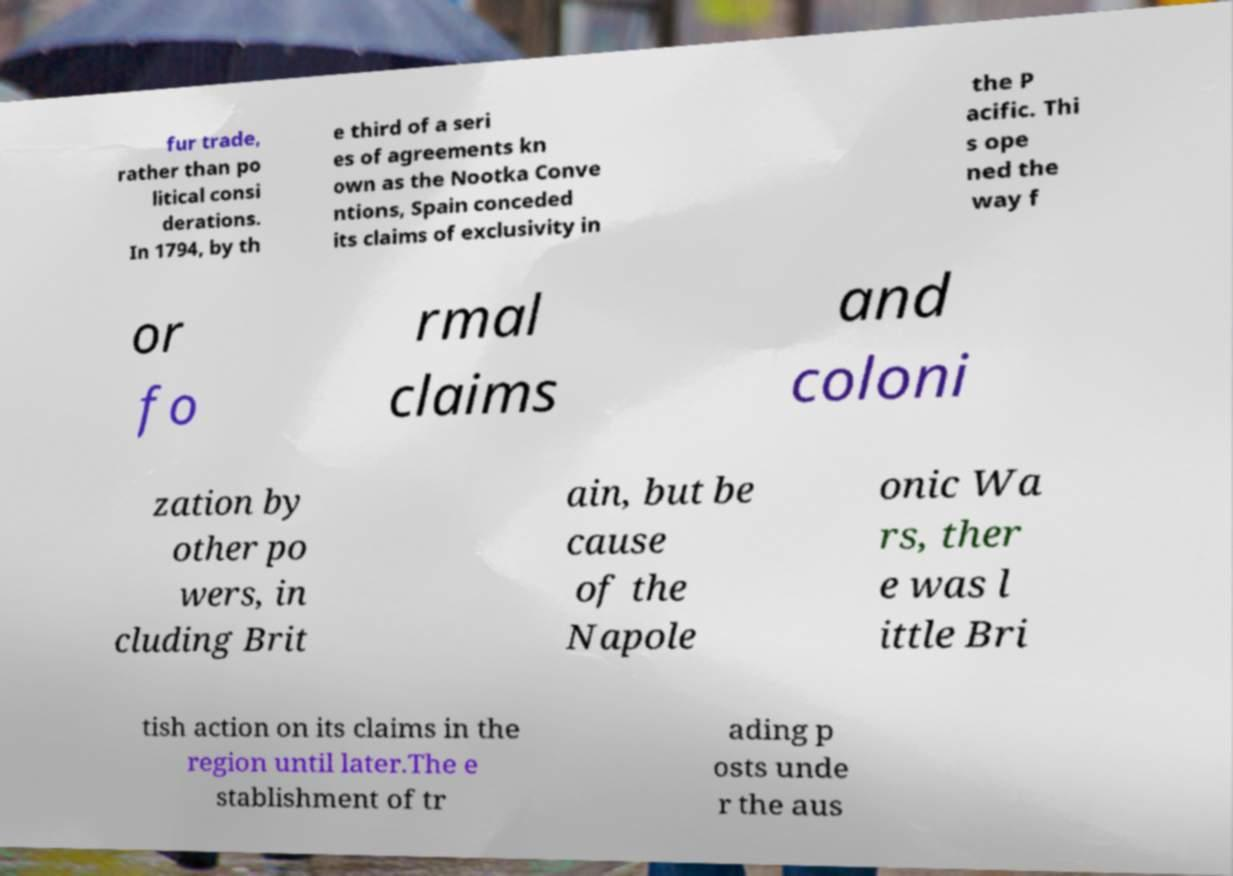Please identify and transcribe the text found in this image. fur trade, rather than po litical consi derations. In 1794, by th e third of a seri es of agreements kn own as the Nootka Conve ntions, Spain conceded its claims of exclusivity in the P acific. Thi s ope ned the way f or fo rmal claims and coloni zation by other po wers, in cluding Brit ain, but be cause of the Napole onic Wa rs, ther e was l ittle Bri tish action on its claims in the region until later.The e stablishment of tr ading p osts unde r the aus 